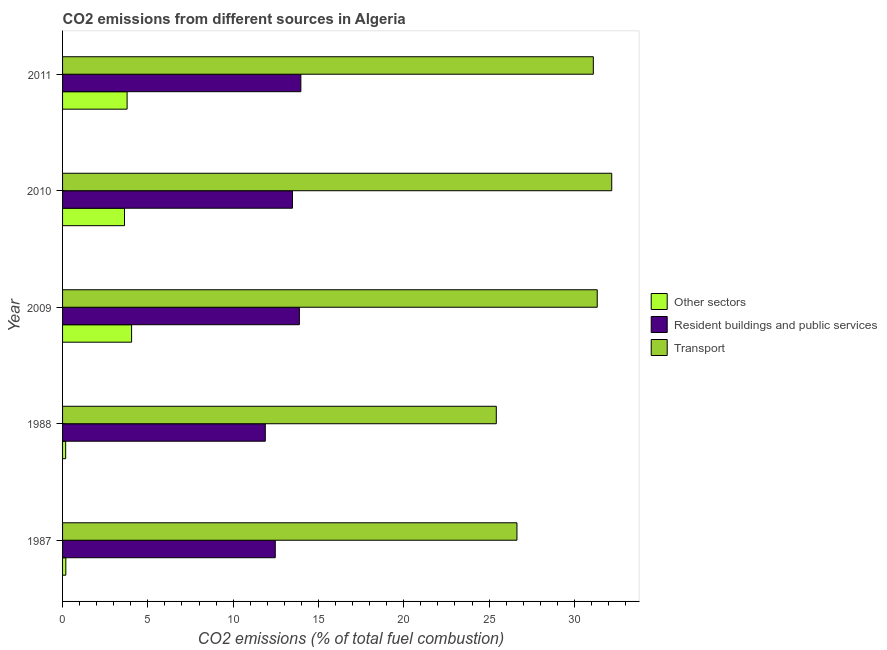Are the number of bars per tick equal to the number of legend labels?
Make the answer very short. Yes. Are the number of bars on each tick of the Y-axis equal?
Provide a succinct answer. Yes. How many bars are there on the 2nd tick from the bottom?
Give a very brief answer. 3. In how many cases, is the number of bars for a given year not equal to the number of legend labels?
Offer a terse response. 0. What is the percentage of co2 emissions from other sectors in 2011?
Provide a succinct answer. 3.78. Across all years, what is the maximum percentage of co2 emissions from resident buildings and public services?
Give a very brief answer. 13.97. Across all years, what is the minimum percentage of co2 emissions from transport?
Provide a short and direct response. 25.42. In which year was the percentage of co2 emissions from transport minimum?
Your answer should be very brief. 1988. What is the total percentage of co2 emissions from other sectors in the graph?
Your answer should be compact. 11.83. What is the difference between the percentage of co2 emissions from other sectors in 1987 and that in 1988?
Provide a short and direct response. 0.01. What is the difference between the percentage of co2 emissions from resident buildings and public services in 2009 and the percentage of co2 emissions from transport in 2011?
Offer a very short reply. -17.23. What is the average percentage of co2 emissions from transport per year?
Provide a succinct answer. 29.34. In the year 1988, what is the difference between the percentage of co2 emissions from other sectors and percentage of co2 emissions from resident buildings and public services?
Ensure brevity in your answer.  -11.7. What is the ratio of the percentage of co2 emissions from transport in 1988 to that in 2010?
Keep it short and to the point. 0.79. Is the difference between the percentage of co2 emissions from other sectors in 1988 and 2010 greater than the difference between the percentage of co2 emissions from transport in 1988 and 2010?
Ensure brevity in your answer.  Yes. What is the difference between the highest and the second highest percentage of co2 emissions from transport?
Make the answer very short. 0.85. What is the difference between the highest and the lowest percentage of co2 emissions from resident buildings and public services?
Provide a succinct answer. 2.08. In how many years, is the percentage of co2 emissions from transport greater than the average percentage of co2 emissions from transport taken over all years?
Your response must be concise. 3. What does the 2nd bar from the top in 2011 represents?
Your answer should be very brief. Resident buildings and public services. What does the 3rd bar from the bottom in 2009 represents?
Your response must be concise. Transport. Are the values on the major ticks of X-axis written in scientific E-notation?
Provide a succinct answer. No. Where does the legend appear in the graph?
Offer a terse response. Center right. How many legend labels are there?
Ensure brevity in your answer.  3. What is the title of the graph?
Offer a very short reply. CO2 emissions from different sources in Algeria. What is the label or title of the X-axis?
Your answer should be very brief. CO2 emissions (% of total fuel combustion). What is the label or title of the Y-axis?
Provide a short and direct response. Year. What is the CO2 emissions (% of total fuel combustion) in Other sectors in 1987?
Offer a terse response. 0.19. What is the CO2 emissions (% of total fuel combustion) in Resident buildings and public services in 1987?
Your answer should be very brief. 12.47. What is the CO2 emissions (% of total fuel combustion) of Transport in 1987?
Provide a short and direct response. 26.64. What is the CO2 emissions (% of total fuel combustion) in Other sectors in 1988?
Your answer should be very brief. 0.18. What is the CO2 emissions (% of total fuel combustion) of Resident buildings and public services in 1988?
Offer a very short reply. 11.88. What is the CO2 emissions (% of total fuel combustion) of Transport in 1988?
Your response must be concise. 25.42. What is the CO2 emissions (% of total fuel combustion) of Other sectors in 2009?
Offer a very short reply. 4.05. What is the CO2 emissions (% of total fuel combustion) of Resident buildings and public services in 2009?
Your answer should be compact. 13.88. What is the CO2 emissions (% of total fuel combustion) in Transport in 2009?
Provide a short and direct response. 31.34. What is the CO2 emissions (% of total fuel combustion) of Other sectors in 2010?
Your response must be concise. 3.63. What is the CO2 emissions (% of total fuel combustion) of Resident buildings and public services in 2010?
Offer a very short reply. 13.48. What is the CO2 emissions (% of total fuel combustion) in Transport in 2010?
Provide a short and direct response. 32.19. What is the CO2 emissions (% of total fuel combustion) of Other sectors in 2011?
Make the answer very short. 3.78. What is the CO2 emissions (% of total fuel combustion) of Resident buildings and public services in 2011?
Provide a succinct answer. 13.97. What is the CO2 emissions (% of total fuel combustion) in Transport in 2011?
Ensure brevity in your answer.  31.11. Across all years, what is the maximum CO2 emissions (% of total fuel combustion) of Other sectors?
Your answer should be compact. 4.05. Across all years, what is the maximum CO2 emissions (% of total fuel combustion) of Resident buildings and public services?
Your answer should be compact. 13.97. Across all years, what is the maximum CO2 emissions (% of total fuel combustion) in Transport?
Provide a short and direct response. 32.19. Across all years, what is the minimum CO2 emissions (% of total fuel combustion) of Other sectors?
Make the answer very short. 0.18. Across all years, what is the minimum CO2 emissions (% of total fuel combustion) of Resident buildings and public services?
Give a very brief answer. 11.88. Across all years, what is the minimum CO2 emissions (% of total fuel combustion) of Transport?
Keep it short and to the point. 25.42. What is the total CO2 emissions (% of total fuel combustion) in Other sectors in the graph?
Make the answer very short. 11.83. What is the total CO2 emissions (% of total fuel combustion) in Resident buildings and public services in the graph?
Keep it short and to the point. 65.68. What is the total CO2 emissions (% of total fuel combustion) in Transport in the graph?
Make the answer very short. 146.71. What is the difference between the CO2 emissions (% of total fuel combustion) of Other sectors in 1987 and that in 1988?
Your response must be concise. 0.01. What is the difference between the CO2 emissions (% of total fuel combustion) of Resident buildings and public services in 1987 and that in 1988?
Ensure brevity in your answer.  0.58. What is the difference between the CO2 emissions (% of total fuel combustion) in Transport in 1987 and that in 1988?
Make the answer very short. 1.21. What is the difference between the CO2 emissions (% of total fuel combustion) of Other sectors in 1987 and that in 2009?
Give a very brief answer. -3.85. What is the difference between the CO2 emissions (% of total fuel combustion) in Resident buildings and public services in 1987 and that in 2009?
Your answer should be compact. -1.41. What is the difference between the CO2 emissions (% of total fuel combustion) in Transport in 1987 and that in 2009?
Offer a very short reply. -4.71. What is the difference between the CO2 emissions (% of total fuel combustion) in Other sectors in 1987 and that in 2010?
Provide a short and direct response. -3.44. What is the difference between the CO2 emissions (% of total fuel combustion) in Resident buildings and public services in 1987 and that in 2010?
Your response must be concise. -1.01. What is the difference between the CO2 emissions (% of total fuel combustion) of Transport in 1987 and that in 2010?
Offer a very short reply. -5.56. What is the difference between the CO2 emissions (% of total fuel combustion) in Other sectors in 1987 and that in 2011?
Offer a very short reply. -3.59. What is the difference between the CO2 emissions (% of total fuel combustion) of Resident buildings and public services in 1987 and that in 2011?
Make the answer very short. -1.5. What is the difference between the CO2 emissions (% of total fuel combustion) in Transport in 1987 and that in 2011?
Keep it short and to the point. -4.48. What is the difference between the CO2 emissions (% of total fuel combustion) in Other sectors in 1988 and that in 2009?
Keep it short and to the point. -3.86. What is the difference between the CO2 emissions (% of total fuel combustion) of Resident buildings and public services in 1988 and that in 2009?
Make the answer very short. -2. What is the difference between the CO2 emissions (% of total fuel combustion) of Transport in 1988 and that in 2009?
Provide a succinct answer. -5.92. What is the difference between the CO2 emissions (% of total fuel combustion) of Other sectors in 1988 and that in 2010?
Make the answer very short. -3.45. What is the difference between the CO2 emissions (% of total fuel combustion) of Resident buildings and public services in 1988 and that in 2010?
Provide a short and direct response. -1.59. What is the difference between the CO2 emissions (% of total fuel combustion) in Transport in 1988 and that in 2010?
Offer a very short reply. -6.77. What is the difference between the CO2 emissions (% of total fuel combustion) in Other sectors in 1988 and that in 2011?
Offer a terse response. -3.6. What is the difference between the CO2 emissions (% of total fuel combustion) in Resident buildings and public services in 1988 and that in 2011?
Give a very brief answer. -2.08. What is the difference between the CO2 emissions (% of total fuel combustion) in Transport in 1988 and that in 2011?
Your answer should be very brief. -5.69. What is the difference between the CO2 emissions (% of total fuel combustion) of Other sectors in 2009 and that in 2010?
Provide a short and direct response. 0.42. What is the difference between the CO2 emissions (% of total fuel combustion) of Resident buildings and public services in 2009 and that in 2010?
Your answer should be very brief. 0.41. What is the difference between the CO2 emissions (% of total fuel combustion) in Transport in 2009 and that in 2010?
Your answer should be very brief. -0.85. What is the difference between the CO2 emissions (% of total fuel combustion) in Other sectors in 2009 and that in 2011?
Offer a terse response. 0.26. What is the difference between the CO2 emissions (% of total fuel combustion) of Resident buildings and public services in 2009 and that in 2011?
Your answer should be compact. -0.09. What is the difference between the CO2 emissions (% of total fuel combustion) of Transport in 2009 and that in 2011?
Keep it short and to the point. 0.23. What is the difference between the CO2 emissions (% of total fuel combustion) of Other sectors in 2010 and that in 2011?
Your response must be concise. -0.15. What is the difference between the CO2 emissions (% of total fuel combustion) of Resident buildings and public services in 2010 and that in 2011?
Give a very brief answer. -0.49. What is the difference between the CO2 emissions (% of total fuel combustion) of Transport in 2010 and that in 2011?
Provide a short and direct response. 1.08. What is the difference between the CO2 emissions (% of total fuel combustion) in Other sectors in 1987 and the CO2 emissions (% of total fuel combustion) in Resident buildings and public services in 1988?
Your answer should be compact. -11.69. What is the difference between the CO2 emissions (% of total fuel combustion) in Other sectors in 1987 and the CO2 emissions (% of total fuel combustion) in Transport in 1988?
Offer a very short reply. -25.23. What is the difference between the CO2 emissions (% of total fuel combustion) in Resident buildings and public services in 1987 and the CO2 emissions (% of total fuel combustion) in Transport in 1988?
Keep it short and to the point. -12.96. What is the difference between the CO2 emissions (% of total fuel combustion) of Other sectors in 1987 and the CO2 emissions (% of total fuel combustion) of Resident buildings and public services in 2009?
Provide a short and direct response. -13.69. What is the difference between the CO2 emissions (% of total fuel combustion) of Other sectors in 1987 and the CO2 emissions (% of total fuel combustion) of Transport in 2009?
Keep it short and to the point. -31.15. What is the difference between the CO2 emissions (% of total fuel combustion) of Resident buildings and public services in 1987 and the CO2 emissions (% of total fuel combustion) of Transport in 2009?
Give a very brief answer. -18.87. What is the difference between the CO2 emissions (% of total fuel combustion) of Other sectors in 1987 and the CO2 emissions (% of total fuel combustion) of Resident buildings and public services in 2010?
Make the answer very short. -13.28. What is the difference between the CO2 emissions (% of total fuel combustion) of Other sectors in 1987 and the CO2 emissions (% of total fuel combustion) of Transport in 2010?
Keep it short and to the point. -32. What is the difference between the CO2 emissions (% of total fuel combustion) in Resident buildings and public services in 1987 and the CO2 emissions (% of total fuel combustion) in Transport in 2010?
Offer a terse response. -19.72. What is the difference between the CO2 emissions (% of total fuel combustion) of Other sectors in 1987 and the CO2 emissions (% of total fuel combustion) of Resident buildings and public services in 2011?
Provide a succinct answer. -13.78. What is the difference between the CO2 emissions (% of total fuel combustion) in Other sectors in 1987 and the CO2 emissions (% of total fuel combustion) in Transport in 2011?
Keep it short and to the point. -30.92. What is the difference between the CO2 emissions (% of total fuel combustion) in Resident buildings and public services in 1987 and the CO2 emissions (% of total fuel combustion) in Transport in 2011?
Keep it short and to the point. -18.64. What is the difference between the CO2 emissions (% of total fuel combustion) in Other sectors in 1988 and the CO2 emissions (% of total fuel combustion) in Resident buildings and public services in 2009?
Offer a terse response. -13.7. What is the difference between the CO2 emissions (% of total fuel combustion) of Other sectors in 1988 and the CO2 emissions (% of total fuel combustion) of Transport in 2009?
Offer a very short reply. -31.16. What is the difference between the CO2 emissions (% of total fuel combustion) in Resident buildings and public services in 1988 and the CO2 emissions (% of total fuel combustion) in Transport in 2009?
Your response must be concise. -19.46. What is the difference between the CO2 emissions (% of total fuel combustion) in Other sectors in 1988 and the CO2 emissions (% of total fuel combustion) in Resident buildings and public services in 2010?
Provide a succinct answer. -13.29. What is the difference between the CO2 emissions (% of total fuel combustion) in Other sectors in 1988 and the CO2 emissions (% of total fuel combustion) in Transport in 2010?
Give a very brief answer. -32.01. What is the difference between the CO2 emissions (% of total fuel combustion) in Resident buildings and public services in 1988 and the CO2 emissions (% of total fuel combustion) in Transport in 2010?
Your answer should be compact. -20.31. What is the difference between the CO2 emissions (% of total fuel combustion) of Other sectors in 1988 and the CO2 emissions (% of total fuel combustion) of Resident buildings and public services in 2011?
Make the answer very short. -13.79. What is the difference between the CO2 emissions (% of total fuel combustion) in Other sectors in 1988 and the CO2 emissions (% of total fuel combustion) in Transport in 2011?
Provide a short and direct response. -30.93. What is the difference between the CO2 emissions (% of total fuel combustion) of Resident buildings and public services in 1988 and the CO2 emissions (% of total fuel combustion) of Transport in 2011?
Offer a terse response. -19.23. What is the difference between the CO2 emissions (% of total fuel combustion) in Other sectors in 2009 and the CO2 emissions (% of total fuel combustion) in Resident buildings and public services in 2010?
Give a very brief answer. -9.43. What is the difference between the CO2 emissions (% of total fuel combustion) in Other sectors in 2009 and the CO2 emissions (% of total fuel combustion) in Transport in 2010?
Ensure brevity in your answer.  -28.15. What is the difference between the CO2 emissions (% of total fuel combustion) in Resident buildings and public services in 2009 and the CO2 emissions (% of total fuel combustion) in Transport in 2010?
Your answer should be compact. -18.31. What is the difference between the CO2 emissions (% of total fuel combustion) of Other sectors in 2009 and the CO2 emissions (% of total fuel combustion) of Resident buildings and public services in 2011?
Your answer should be very brief. -9.92. What is the difference between the CO2 emissions (% of total fuel combustion) in Other sectors in 2009 and the CO2 emissions (% of total fuel combustion) in Transport in 2011?
Your answer should be very brief. -27.07. What is the difference between the CO2 emissions (% of total fuel combustion) of Resident buildings and public services in 2009 and the CO2 emissions (% of total fuel combustion) of Transport in 2011?
Offer a very short reply. -17.23. What is the difference between the CO2 emissions (% of total fuel combustion) in Other sectors in 2010 and the CO2 emissions (% of total fuel combustion) in Resident buildings and public services in 2011?
Give a very brief answer. -10.34. What is the difference between the CO2 emissions (% of total fuel combustion) of Other sectors in 2010 and the CO2 emissions (% of total fuel combustion) of Transport in 2011?
Make the answer very short. -27.48. What is the difference between the CO2 emissions (% of total fuel combustion) of Resident buildings and public services in 2010 and the CO2 emissions (% of total fuel combustion) of Transport in 2011?
Ensure brevity in your answer.  -17.64. What is the average CO2 emissions (% of total fuel combustion) in Other sectors per year?
Offer a very short reply. 2.37. What is the average CO2 emissions (% of total fuel combustion) in Resident buildings and public services per year?
Keep it short and to the point. 13.14. What is the average CO2 emissions (% of total fuel combustion) in Transport per year?
Ensure brevity in your answer.  29.34. In the year 1987, what is the difference between the CO2 emissions (% of total fuel combustion) of Other sectors and CO2 emissions (% of total fuel combustion) of Resident buildings and public services?
Your answer should be compact. -12.28. In the year 1987, what is the difference between the CO2 emissions (% of total fuel combustion) in Other sectors and CO2 emissions (% of total fuel combustion) in Transport?
Give a very brief answer. -26.44. In the year 1987, what is the difference between the CO2 emissions (% of total fuel combustion) in Resident buildings and public services and CO2 emissions (% of total fuel combustion) in Transport?
Ensure brevity in your answer.  -14.17. In the year 1988, what is the difference between the CO2 emissions (% of total fuel combustion) of Other sectors and CO2 emissions (% of total fuel combustion) of Resident buildings and public services?
Make the answer very short. -11.7. In the year 1988, what is the difference between the CO2 emissions (% of total fuel combustion) in Other sectors and CO2 emissions (% of total fuel combustion) in Transport?
Your answer should be very brief. -25.24. In the year 1988, what is the difference between the CO2 emissions (% of total fuel combustion) in Resident buildings and public services and CO2 emissions (% of total fuel combustion) in Transport?
Keep it short and to the point. -13.54. In the year 2009, what is the difference between the CO2 emissions (% of total fuel combustion) in Other sectors and CO2 emissions (% of total fuel combustion) in Resident buildings and public services?
Your answer should be very brief. -9.84. In the year 2009, what is the difference between the CO2 emissions (% of total fuel combustion) of Other sectors and CO2 emissions (% of total fuel combustion) of Transport?
Make the answer very short. -27.3. In the year 2009, what is the difference between the CO2 emissions (% of total fuel combustion) of Resident buildings and public services and CO2 emissions (% of total fuel combustion) of Transport?
Keep it short and to the point. -17.46. In the year 2010, what is the difference between the CO2 emissions (% of total fuel combustion) in Other sectors and CO2 emissions (% of total fuel combustion) in Resident buildings and public services?
Offer a very short reply. -9.85. In the year 2010, what is the difference between the CO2 emissions (% of total fuel combustion) of Other sectors and CO2 emissions (% of total fuel combustion) of Transport?
Your answer should be compact. -28.56. In the year 2010, what is the difference between the CO2 emissions (% of total fuel combustion) of Resident buildings and public services and CO2 emissions (% of total fuel combustion) of Transport?
Offer a very short reply. -18.72. In the year 2011, what is the difference between the CO2 emissions (% of total fuel combustion) of Other sectors and CO2 emissions (% of total fuel combustion) of Resident buildings and public services?
Offer a very short reply. -10.18. In the year 2011, what is the difference between the CO2 emissions (% of total fuel combustion) of Other sectors and CO2 emissions (% of total fuel combustion) of Transport?
Keep it short and to the point. -27.33. In the year 2011, what is the difference between the CO2 emissions (% of total fuel combustion) in Resident buildings and public services and CO2 emissions (% of total fuel combustion) in Transport?
Provide a succinct answer. -17.14. What is the ratio of the CO2 emissions (% of total fuel combustion) of Other sectors in 1987 to that in 1988?
Ensure brevity in your answer.  1.05. What is the ratio of the CO2 emissions (% of total fuel combustion) in Resident buildings and public services in 1987 to that in 1988?
Your answer should be very brief. 1.05. What is the ratio of the CO2 emissions (% of total fuel combustion) of Transport in 1987 to that in 1988?
Your response must be concise. 1.05. What is the ratio of the CO2 emissions (% of total fuel combustion) of Other sectors in 1987 to that in 2009?
Your answer should be compact. 0.05. What is the ratio of the CO2 emissions (% of total fuel combustion) in Resident buildings and public services in 1987 to that in 2009?
Your answer should be very brief. 0.9. What is the ratio of the CO2 emissions (% of total fuel combustion) of Transport in 1987 to that in 2009?
Your response must be concise. 0.85. What is the ratio of the CO2 emissions (% of total fuel combustion) in Other sectors in 1987 to that in 2010?
Make the answer very short. 0.05. What is the ratio of the CO2 emissions (% of total fuel combustion) in Resident buildings and public services in 1987 to that in 2010?
Provide a short and direct response. 0.93. What is the ratio of the CO2 emissions (% of total fuel combustion) of Transport in 1987 to that in 2010?
Offer a terse response. 0.83. What is the ratio of the CO2 emissions (% of total fuel combustion) of Other sectors in 1987 to that in 2011?
Ensure brevity in your answer.  0.05. What is the ratio of the CO2 emissions (% of total fuel combustion) of Resident buildings and public services in 1987 to that in 2011?
Your answer should be very brief. 0.89. What is the ratio of the CO2 emissions (% of total fuel combustion) of Transport in 1987 to that in 2011?
Ensure brevity in your answer.  0.86. What is the ratio of the CO2 emissions (% of total fuel combustion) of Other sectors in 1988 to that in 2009?
Your answer should be very brief. 0.04. What is the ratio of the CO2 emissions (% of total fuel combustion) of Resident buildings and public services in 1988 to that in 2009?
Your response must be concise. 0.86. What is the ratio of the CO2 emissions (% of total fuel combustion) of Transport in 1988 to that in 2009?
Give a very brief answer. 0.81. What is the ratio of the CO2 emissions (% of total fuel combustion) in Other sectors in 1988 to that in 2010?
Your answer should be very brief. 0.05. What is the ratio of the CO2 emissions (% of total fuel combustion) in Resident buildings and public services in 1988 to that in 2010?
Your response must be concise. 0.88. What is the ratio of the CO2 emissions (% of total fuel combustion) of Transport in 1988 to that in 2010?
Provide a short and direct response. 0.79. What is the ratio of the CO2 emissions (% of total fuel combustion) of Other sectors in 1988 to that in 2011?
Your answer should be compact. 0.05. What is the ratio of the CO2 emissions (% of total fuel combustion) of Resident buildings and public services in 1988 to that in 2011?
Provide a short and direct response. 0.85. What is the ratio of the CO2 emissions (% of total fuel combustion) in Transport in 1988 to that in 2011?
Give a very brief answer. 0.82. What is the ratio of the CO2 emissions (% of total fuel combustion) of Other sectors in 2009 to that in 2010?
Provide a short and direct response. 1.11. What is the ratio of the CO2 emissions (% of total fuel combustion) in Resident buildings and public services in 2009 to that in 2010?
Make the answer very short. 1.03. What is the ratio of the CO2 emissions (% of total fuel combustion) in Transport in 2009 to that in 2010?
Provide a succinct answer. 0.97. What is the ratio of the CO2 emissions (% of total fuel combustion) in Other sectors in 2009 to that in 2011?
Provide a succinct answer. 1.07. What is the ratio of the CO2 emissions (% of total fuel combustion) of Transport in 2009 to that in 2011?
Ensure brevity in your answer.  1.01. What is the ratio of the CO2 emissions (% of total fuel combustion) of Other sectors in 2010 to that in 2011?
Ensure brevity in your answer.  0.96. What is the ratio of the CO2 emissions (% of total fuel combustion) in Resident buildings and public services in 2010 to that in 2011?
Provide a short and direct response. 0.96. What is the ratio of the CO2 emissions (% of total fuel combustion) of Transport in 2010 to that in 2011?
Offer a terse response. 1.03. What is the difference between the highest and the second highest CO2 emissions (% of total fuel combustion) of Other sectors?
Provide a succinct answer. 0.26. What is the difference between the highest and the second highest CO2 emissions (% of total fuel combustion) of Resident buildings and public services?
Your answer should be very brief. 0.09. What is the difference between the highest and the second highest CO2 emissions (% of total fuel combustion) in Transport?
Your answer should be compact. 0.85. What is the difference between the highest and the lowest CO2 emissions (% of total fuel combustion) of Other sectors?
Give a very brief answer. 3.86. What is the difference between the highest and the lowest CO2 emissions (% of total fuel combustion) in Resident buildings and public services?
Keep it short and to the point. 2.08. What is the difference between the highest and the lowest CO2 emissions (% of total fuel combustion) of Transport?
Give a very brief answer. 6.77. 